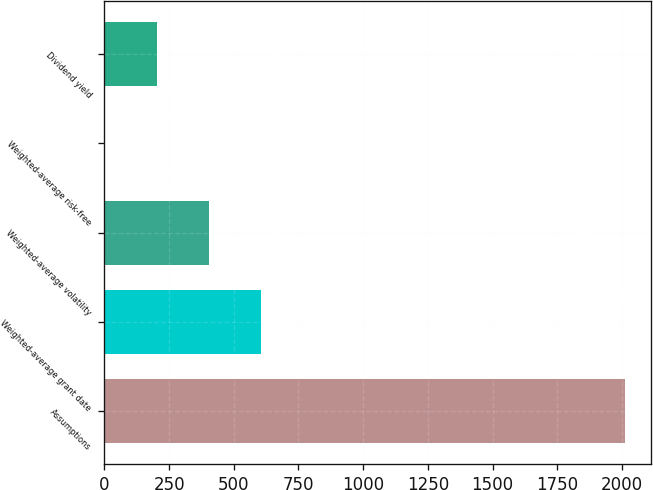Convert chart. <chart><loc_0><loc_0><loc_500><loc_500><bar_chart><fcel>Assumptions<fcel>Weighted-average grant date<fcel>Weighted-average volatility<fcel>Weighted-average risk-free<fcel>Dividend yield<nl><fcel>2012<fcel>603.73<fcel>402.55<fcel>0.19<fcel>201.37<nl></chart> 